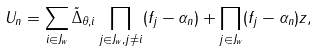Convert formula to latex. <formula><loc_0><loc_0><loc_500><loc_500>U _ { n } = \sum _ { i \in J _ { w } } \tilde { \Delta } _ { \theta , i } \prod _ { j \in J _ { w } , j \neq i } ( f _ { j } - \alpha _ { n } ) + \prod _ { j \in J _ { w } } ( f _ { j } - \alpha _ { n } ) z ,</formula> 